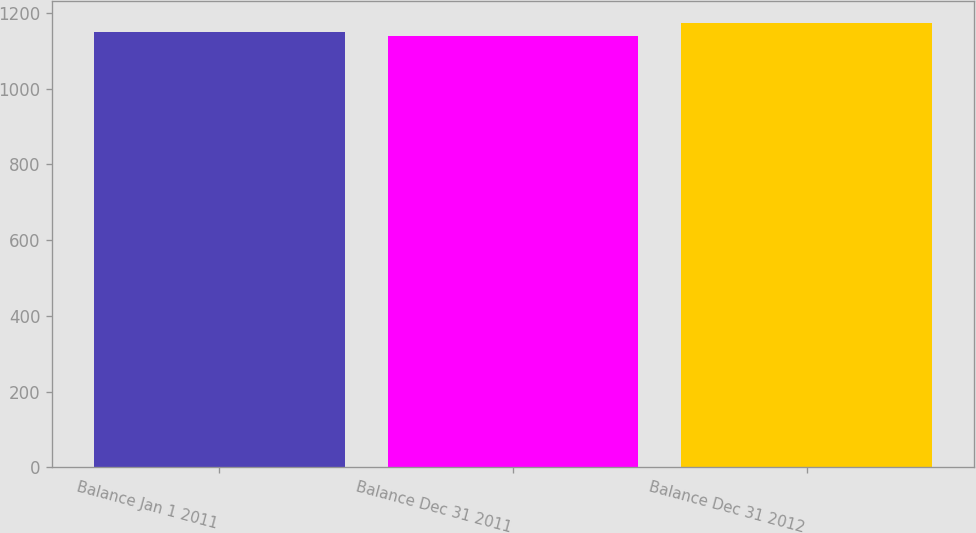Convert chart to OTSL. <chart><loc_0><loc_0><loc_500><loc_500><bar_chart><fcel>Balance Jan 1 2011<fcel>Balance Dec 31 2011<fcel>Balance Dec 31 2012<nl><fcel>1151<fcel>1139<fcel>1173<nl></chart> 